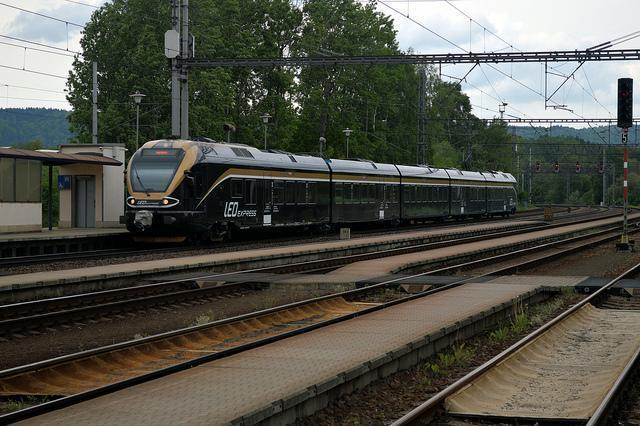How many red trains are there?
Give a very brief answer. 0. 